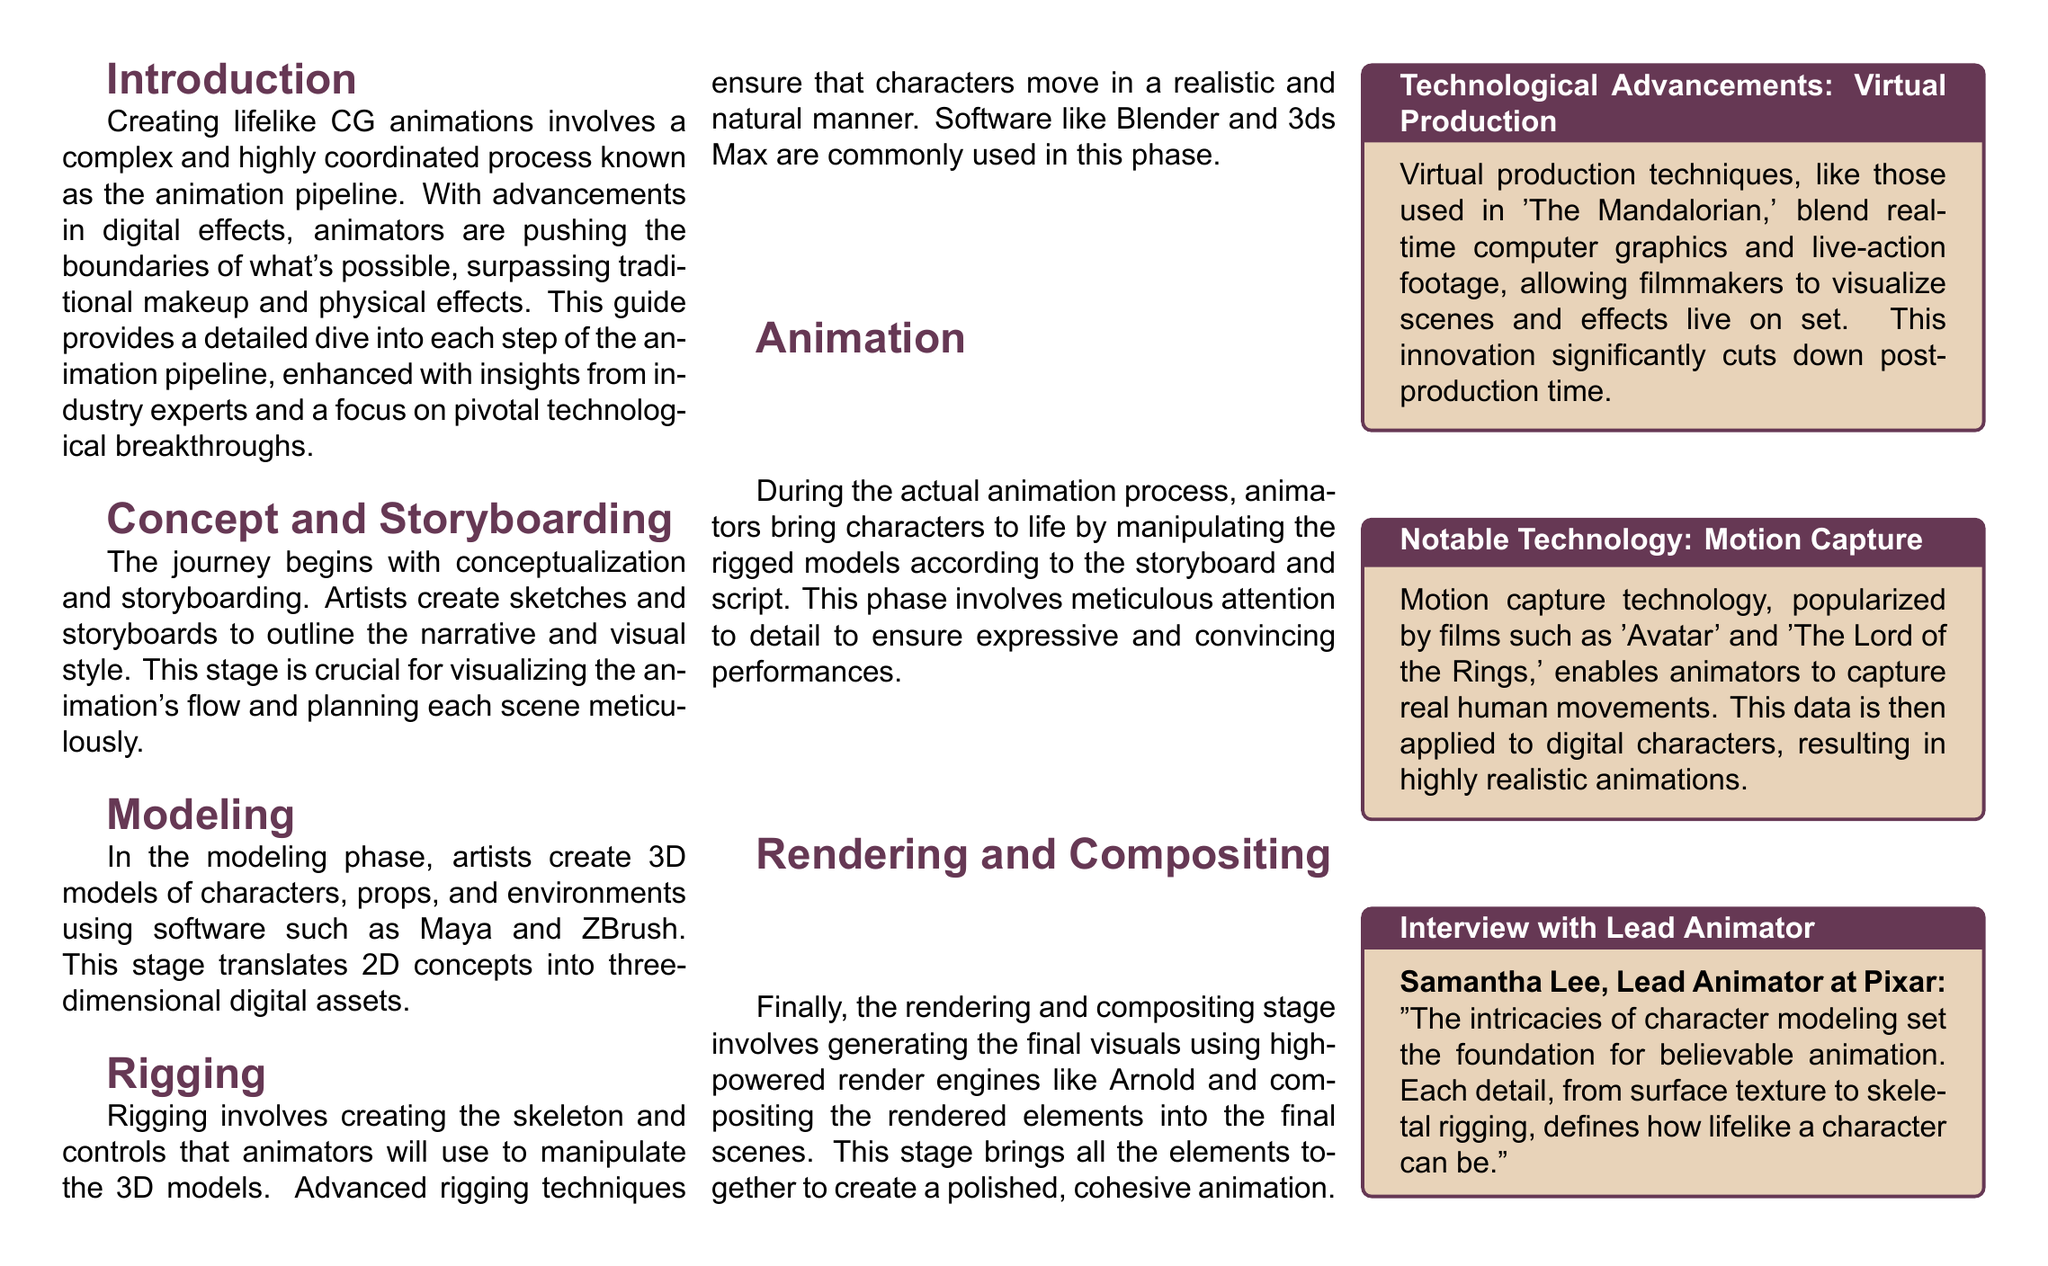What is the title of the guide? The title is highlighted at the top of the document as the main focus, indicating what the content will be about.
Answer: Breaking Down the Animation Pipeline: A Step-by-Step Guide to Bringing Characters to Life Who is the Lead Animator interviewed in the document? The document provides insights from industry professionals, specifically mentioning the Lead Animator.
Answer: Samantha Lee What is the first stage of the animation pipeline? The stages of the animation pipeline are clearly outlined and numbered in the workflow section.
Answer: Concept and Storyboarding Which software is mentioned for modeling? The document references specific software used at various stages in the animation pipeline.
Answer: Maya and ZBrush What technological advancement is highlighted in the sidebar regarding virtual production? The sidebars provide neat summaries of key technologies related to animation, including advancements in virtual production.
Answer: Techniques like those used in 'The Mandalorian' How many stages are there in the animation pipeline? The workflow section lists the stages in a numbered format, making it easy to count them.
Answer: 5 What is emphasized as crucial during the animation phase? The text outlines key elements that animators focus on during their process, signifying its importance.
Answer: Meticulous attention to detail Which render engines are mentioned for the rendering phase? The document specifies tools used in the rendering and compositing stage, providing clarity on the software utilized.
Answer: Arnold 